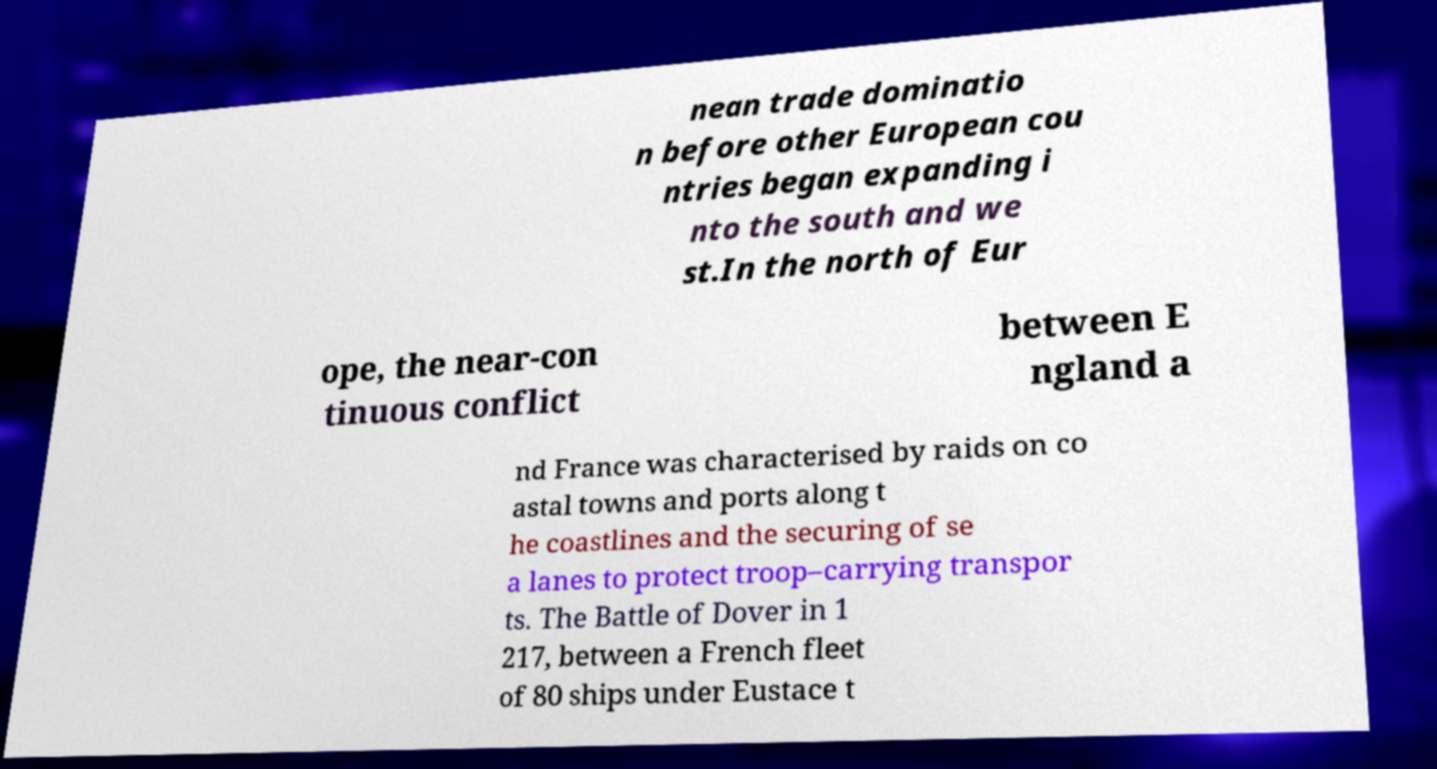Could you extract and type out the text from this image? nean trade dominatio n before other European cou ntries began expanding i nto the south and we st.In the north of Eur ope, the near-con tinuous conflict between E ngland a nd France was characterised by raids on co astal towns and ports along t he coastlines and the securing of se a lanes to protect troop–carrying transpor ts. The Battle of Dover in 1 217, between a French fleet of 80 ships under Eustace t 